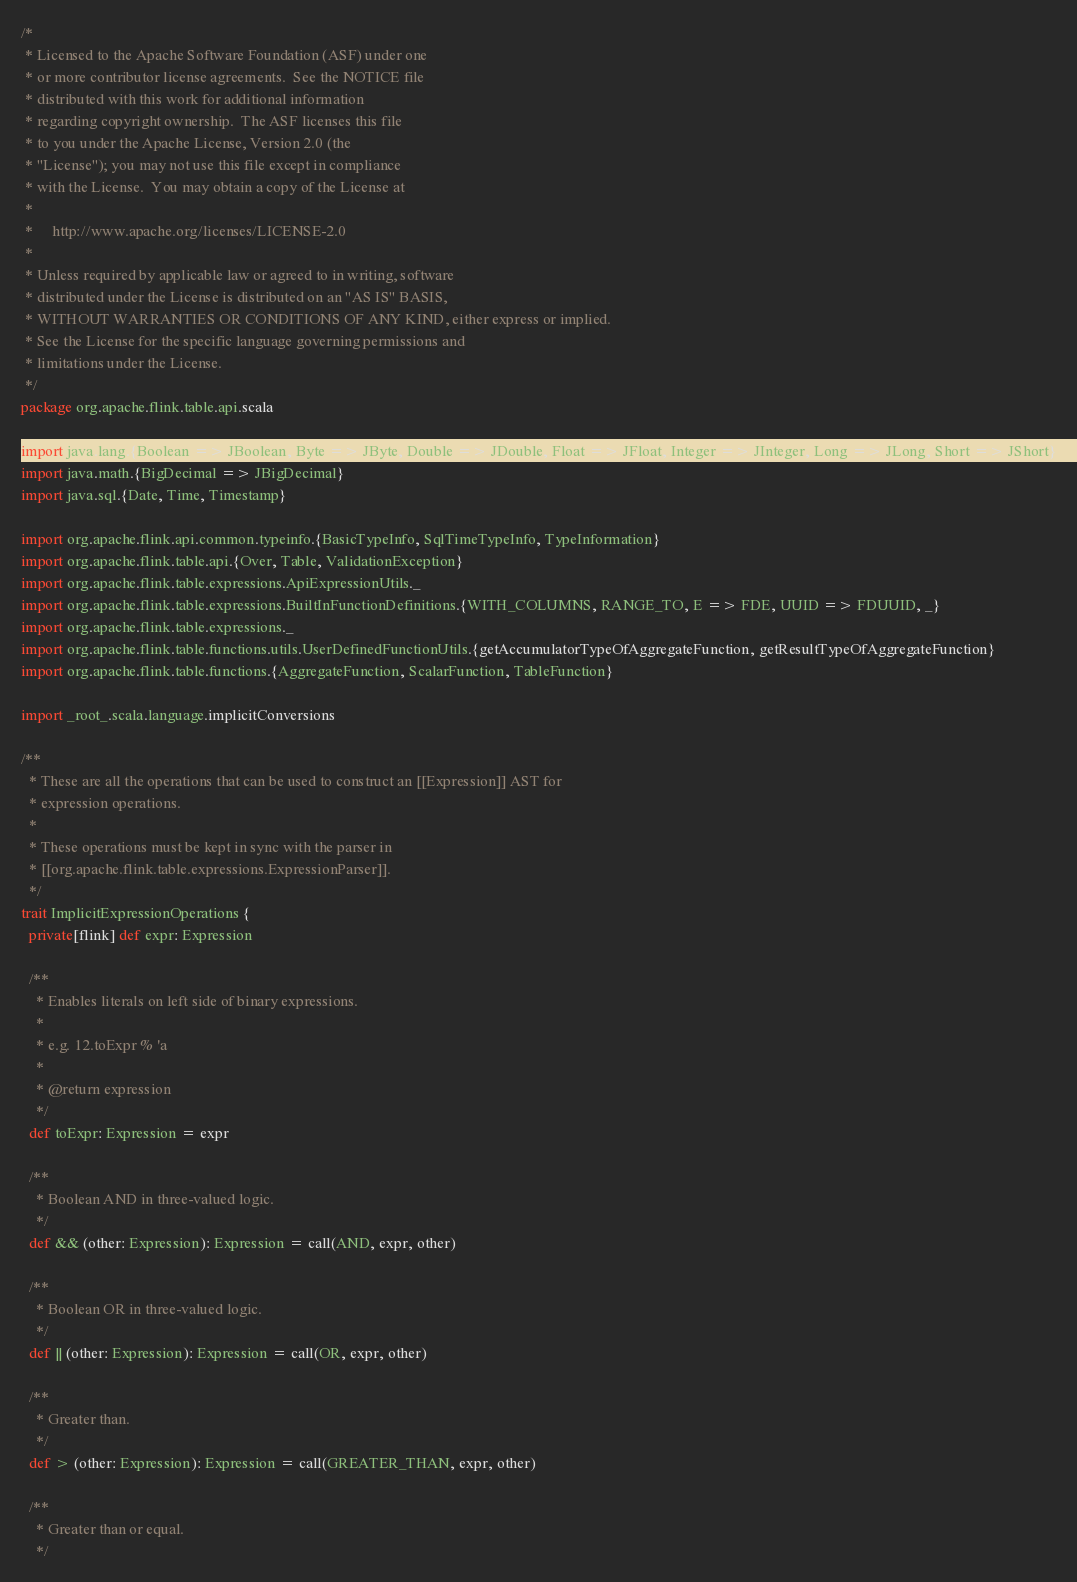Convert code to text. <code><loc_0><loc_0><loc_500><loc_500><_Scala_>/*
 * Licensed to the Apache Software Foundation (ASF) under one
 * or more contributor license agreements.  See the NOTICE file
 * distributed with this work for additional information
 * regarding copyright ownership.  The ASF licenses this file
 * to you under the Apache License, Version 2.0 (the
 * "License"); you may not use this file except in compliance
 * with the License.  You may obtain a copy of the License at
 *
 *     http://www.apache.org/licenses/LICENSE-2.0
 *
 * Unless required by applicable law or agreed to in writing, software
 * distributed under the License is distributed on an "AS IS" BASIS,
 * WITHOUT WARRANTIES OR CONDITIONS OF ANY KIND, either express or implied.
 * See the License for the specific language governing permissions and
 * limitations under the License.
 */
package org.apache.flink.table.api.scala

import java.lang.{Boolean => JBoolean, Byte => JByte, Double => JDouble, Float => JFloat, Integer => JInteger, Long => JLong, Short => JShort}
import java.math.{BigDecimal => JBigDecimal}
import java.sql.{Date, Time, Timestamp}

import org.apache.flink.api.common.typeinfo.{BasicTypeInfo, SqlTimeTypeInfo, TypeInformation}
import org.apache.flink.table.api.{Over, Table, ValidationException}
import org.apache.flink.table.expressions.ApiExpressionUtils._
import org.apache.flink.table.expressions.BuiltInFunctionDefinitions.{WITH_COLUMNS, RANGE_TO, E => FDE, UUID => FDUUID, _}
import org.apache.flink.table.expressions._
import org.apache.flink.table.functions.utils.UserDefinedFunctionUtils.{getAccumulatorTypeOfAggregateFunction, getResultTypeOfAggregateFunction}
import org.apache.flink.table.functions.{AggregateFunction, ScalarFunction, TableFunction}

import _root_.scala.language.implicitConversions

/**
  * These are all the operations that can be used to construct an [[Expression]] AST for
  * expression operations.
  *
  * These operations must be kept in sync with the parser in
  * [[org.apache.flink.table.expressions.ExpressionParser]].
  */
trait ImplicitExpressionOperations {
  private[flink] def expr: Expression

  /**
    * Enables literals on left side of binary expressions.
    *
    * e.g. 12.toExpr % 'a
    *
    * @return expression
    */
  def toExpr: Expression = expr

  /**
    * Boolean AND in three-valued logic.
    */
  def && (other: Expression): Expression = call(AND, expr, other)

  /**
    * Boolean OR in three-valued logic.
    */
  def || (other: Expression): Expression = call(OR, expr, other)

  /**
    * Greater than.
    */
  def > (other: Expression): Expression = call(GREATER_THAN, expr, other)

  /**
    * Greater than or equal.
    */</code> 